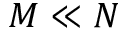<formula> <loc_0><loc_0><loc_500><loc_500>M \ll N</formula> 